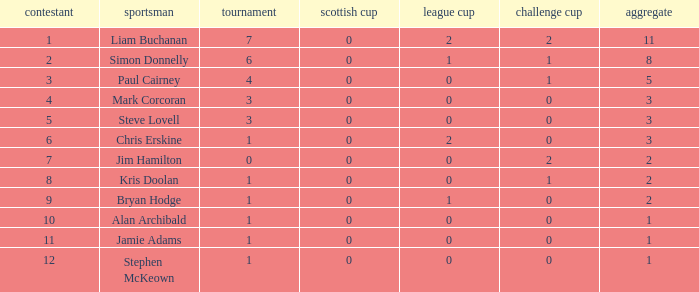What was the lowest number of points scored in the league cup? 0.0. 